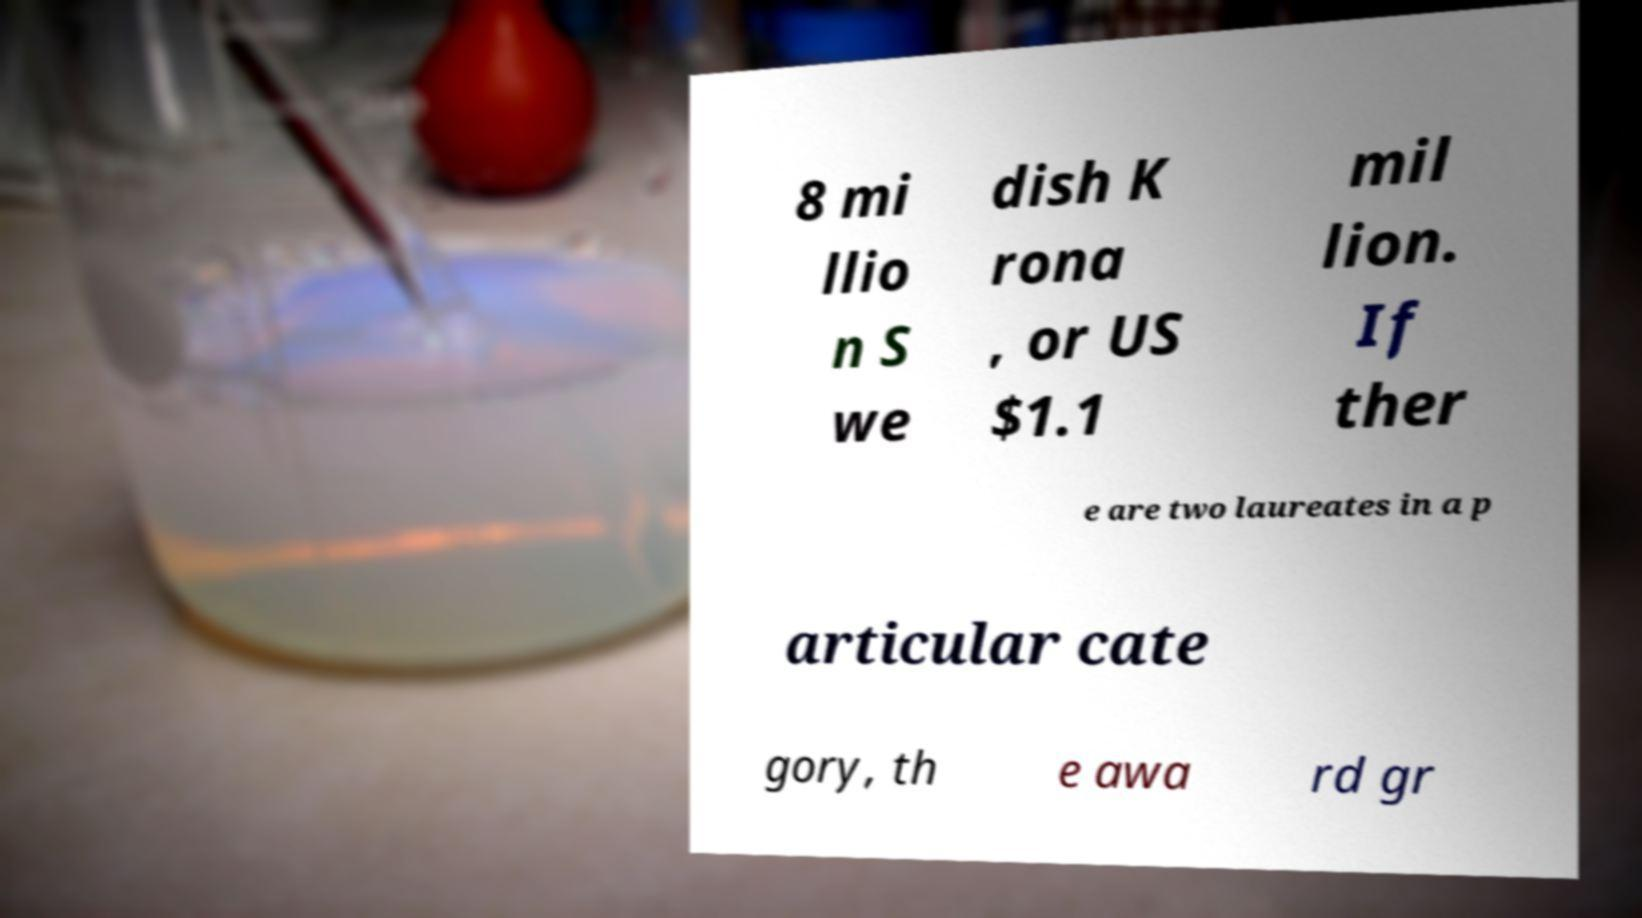Could you assist in decoding the text presented in this image and type it out clearly? 8 mi llio n S we dish K rona , or US $1.1 mil lion. If ther e are two laureates in a p articular cate gory, th e awa rd gr 